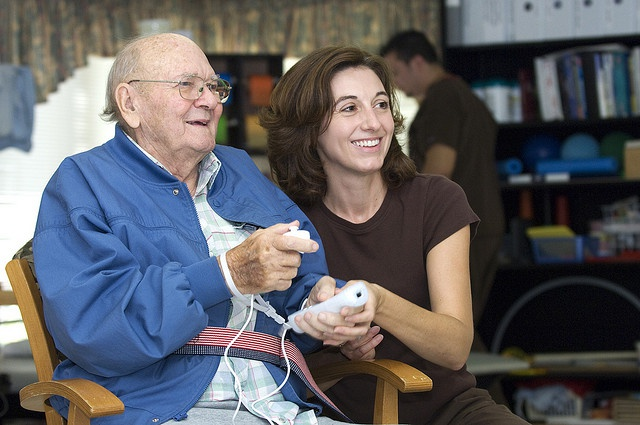Describe the objects in this image and their specific colors. I can see people in gray, blue, lightgray, and tan tones, people in gray, black, and tan tones, people in gray, black, and maroon tones, chair in gray, tan, olive, and maroon tones, and chair in gray, black, maroon, and olive tones in this image. 